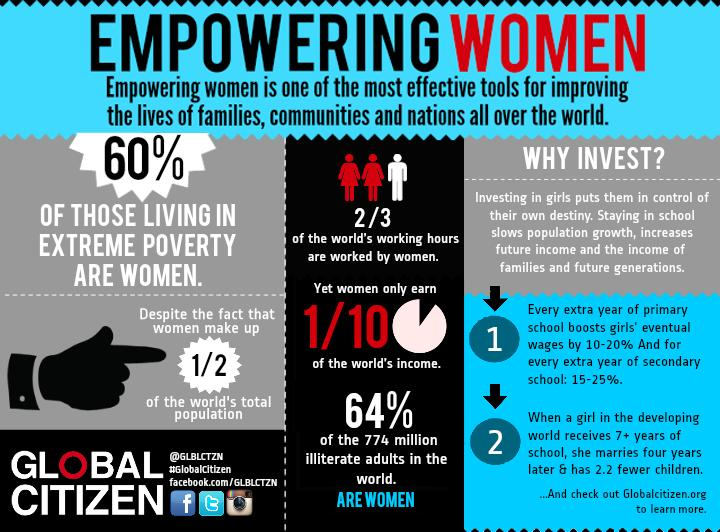Highlight a few significant elements in this photo. The hashtag given is #GlobalCitizen. 